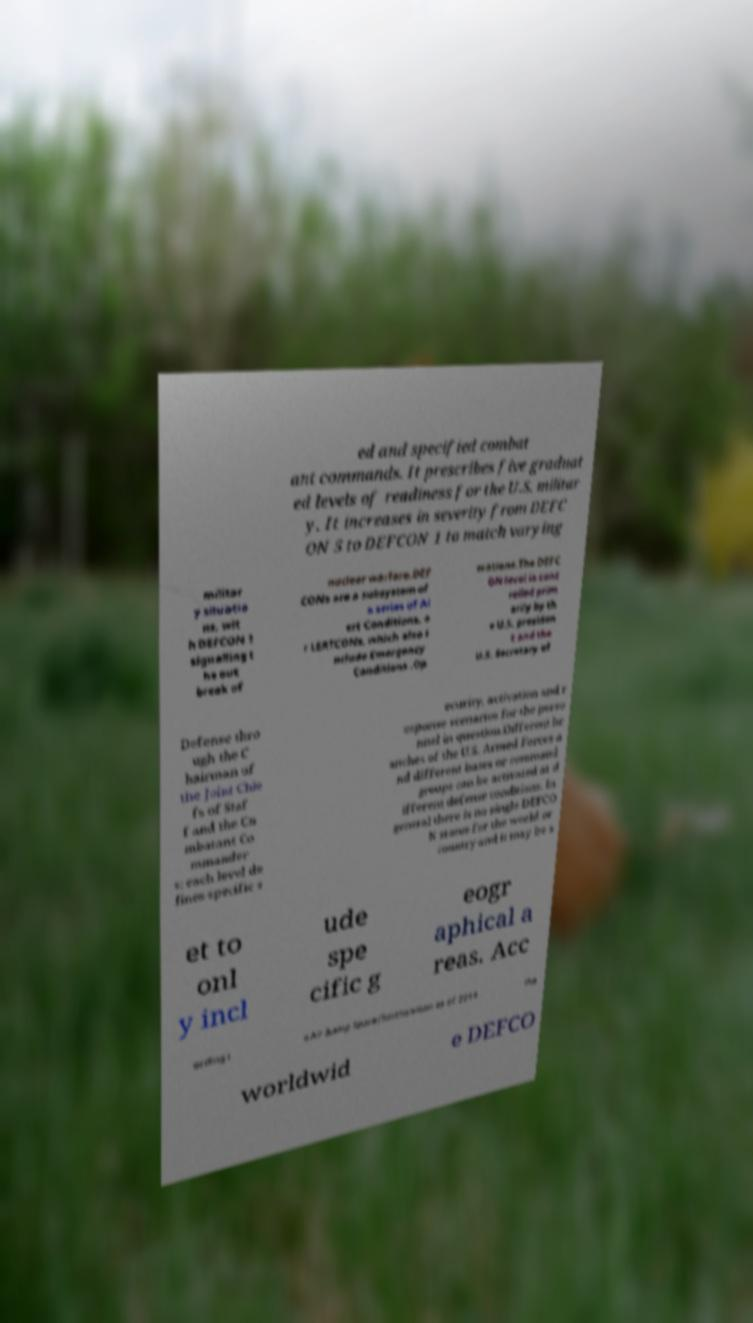There's text embedded in this image that I need extracted. Can you transcribe it verbatim? ed and specified combat ant commands. It prescribes five graduat ed levels of readiness for the U.S. militar y. It increases in severity from DEFC ON 5 to DEFCON 1 to match varying militar y situatio ns, wit h DEFCON 1 signalling t he out break of nuclear warfare.DEF CONs are a subsystem of a series of Al ert Conditions, o r LERTCONs, which also i nclude Emergency Conditions .Op erations.The DEFC ON level is cont rolled prim arily by th e U.S. presiden t and the U.S. Secretary of Defense thro ugh the C hairman of the Joint Chie fs of Staf f and the Co mbatant Co mmander s; each level de fines specific s ecurity, activation and r esponse scenarios for the perso nnel in question.Different br anches of the U.S. Armed Forces a nd different bases or command groups can be activated at d ifferent defense conditions. In general there is no single DEFCO N status for the world or country and it may be s et to onl y incl ude spe cific g eogr aphical a reas. Acc ording t o Air &amp Space/Smithsonian as of 2014 the worldwid e DEFCO 